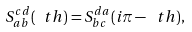<formula> <loc_0><loc_0><loc_500><loc_500>S ^ { c d } _ { a b } ( \ t h ) = S ^ { d a } _ { b c } ( i \pi - \ t h ) ,</formula> 